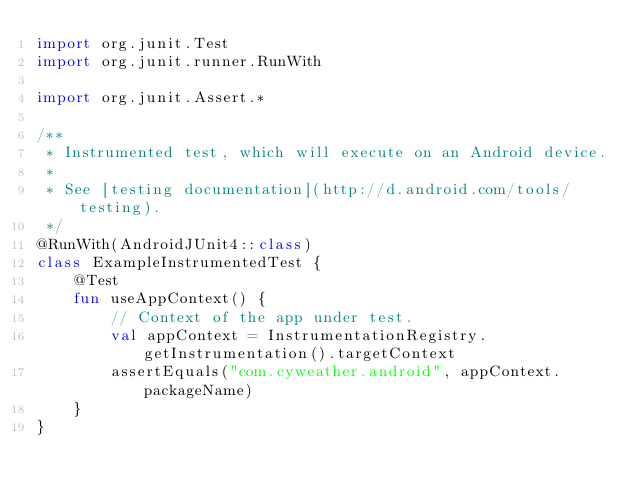Convert code to text. <code><loc_0><loc_0><loc_500><loc_500><_Kotlin_>import org.junit.Test
import org.junit.runner.RunWith

import org.junit.Assert.*

/**
 * Instrumented test, which will execute on an Android device.
 *
 * See [testing documentation](http://d.android.com/tools/testing).
 */
@RunWith(AndroidJUnit4::class)
class ExampleInstrumentedTest {
    @Test
    fun useAppContext() {
        // Context of the app under test.
        val appContext = InstrumentationRegistry.getInstrumentation().targetContext
        assertEquals("com.cyweather.android", appContext.packageName)
    }
}</code> 